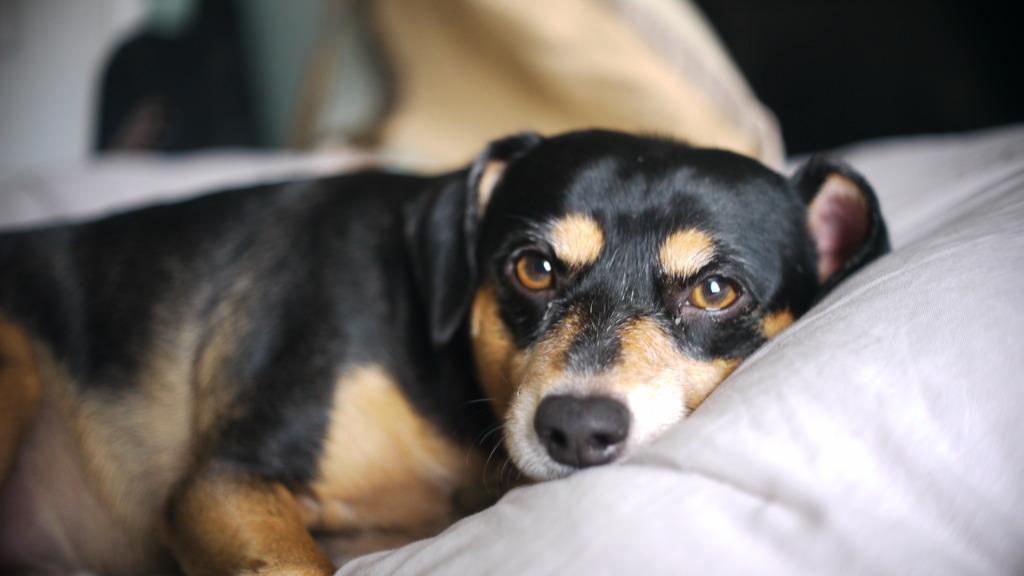Describe this image in one or two sentences. In this image a dog is lying on the bed. Background is blurry. 